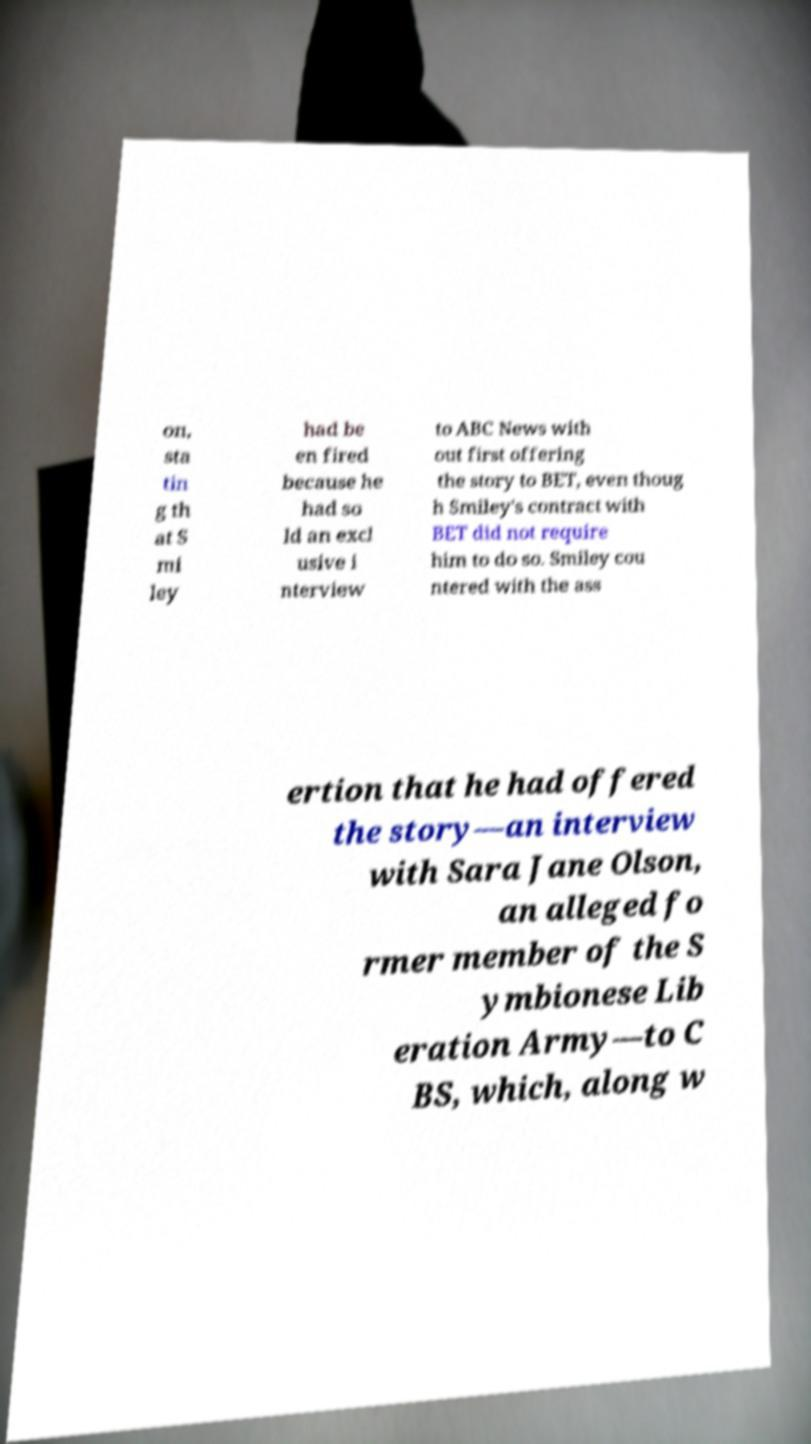For documentation purposes, I need the text within this image transcribed. Could you provide that? on, sta tin g th at S mi ley had be en fired because he had so ld an excl usive i nterview to ABC News with out first offering the story to BET, even thoug h Smiley's contract with BET did not require him to do so. Smiley cou ntered with the ass ertion that he had offered the story—an interview with Sara Jane Olson, an alleged fo rmer member of the S ymbionese Lib eration Army—to C BS, which, along w 